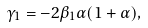Convert formula to latex. <formula><loc_0><loc_0><loc_500><loc_500>\gamma _ { 1 } = - 2 \beta _ { 1 } \alpha ( 1 + \alpha ) ,</formula> 